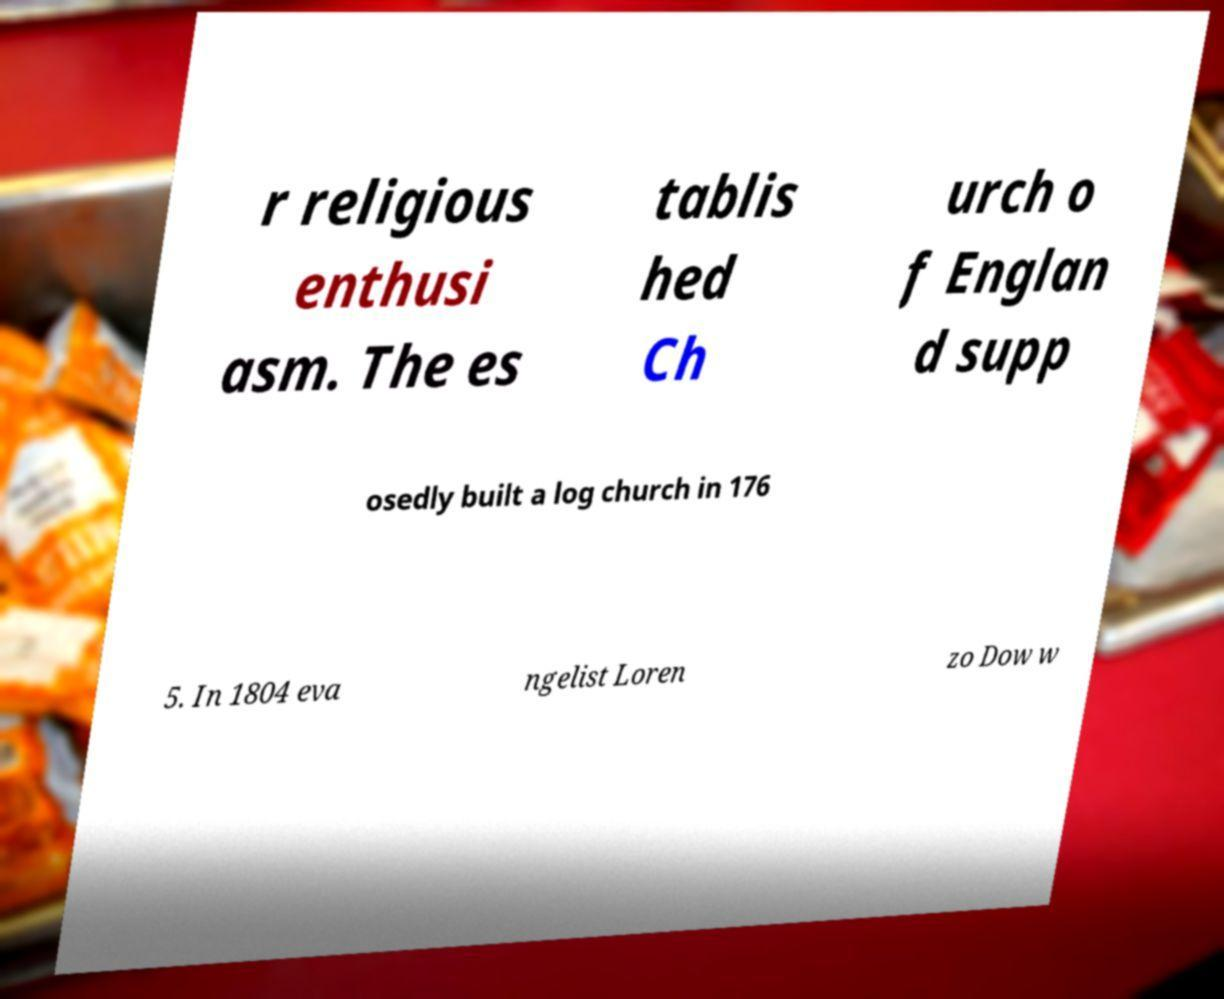Could you assist in decoding the text presented in this image and type it out clearly? r religious enthusi asm. The es tablis hed Ch urch o f Englan d supp osedly built a log church in 176 5. In 1804 eva ngelist Loren zo Dow w 